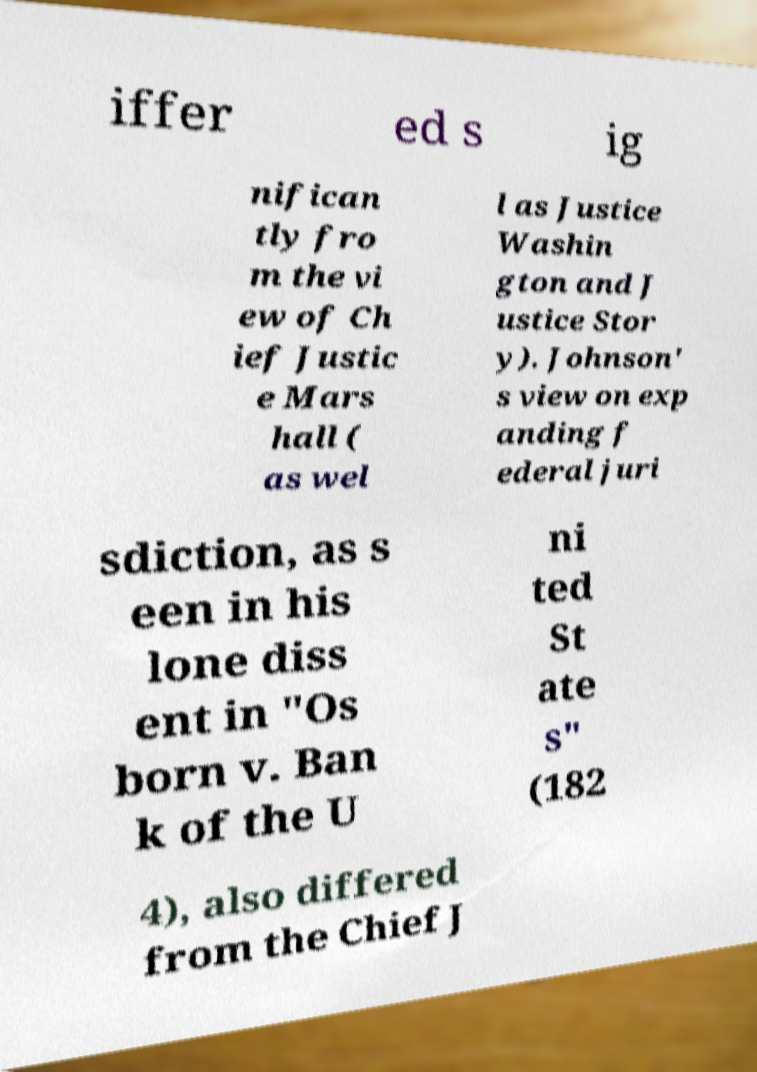What messages or text are displayed in this image? I need them in a readable, typed format. iffer ed s ig nifican tly fro m the vi ew of Ch ief Justic e Mars hall ( as wel l as Justice Washin gton and J ustice Stor y). Johnson' s view on exp anding f ederal juri sdiction, as s een in his lone diss ent in "Os born v. Ban k of the U ni ted St ate s" (182 4), also differed from the Chief J 